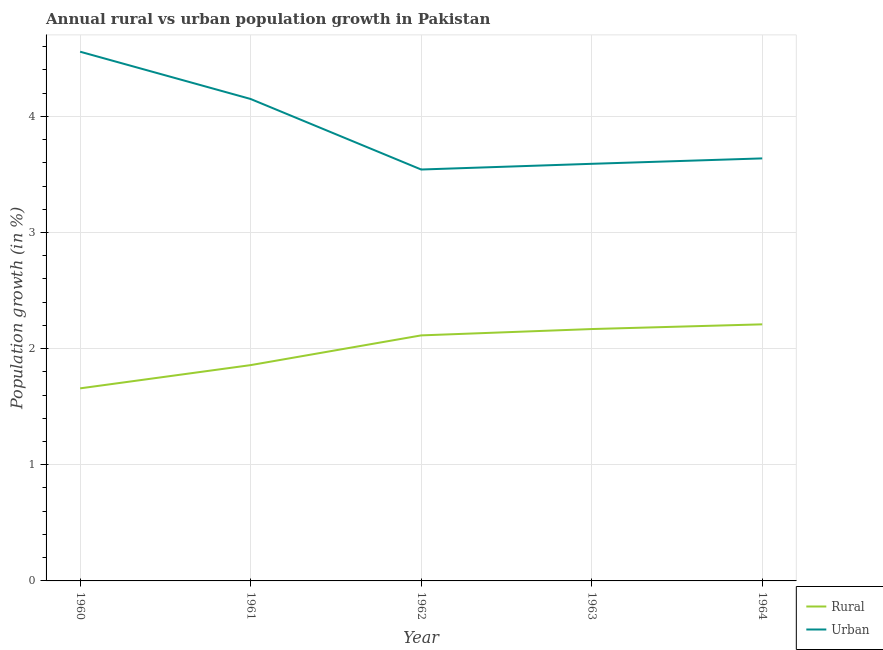How many different coloured lines are there?
Make the answer very short. 2. Is the number of lines equal to the number of legend labels?
Provide a succinct answer. Yes. What is the urban population growth in 1962?
Offer a terse response. 3.54. Across all years, what is the maximum rural population growth?
Ensure brevity in your answer.  2.21. Across all years, what is the minimum rural population growth?
Offer a very short reply. 1.66. In which year was the rural population growth maximum?
Your answer should be very brief. 1964. What is the total urban population growth in the graph?
Ensure brevity in your answer.  19.48. What is the difference between the rural population growth in 1961 and that in 1964?
Make the answer very short. -0.35. What is the difference between the urban population growth in 1960 and the rural population growth in 1962?
Make the answer very short. 2.44. What is the average urban population growth per year?
Your response must be concise. 3.9. In the year 1964, what is the difference between the rural population growth and urban population growth?
Offer a terse response. -1.43. What is the ratio of the rural population growth in 1962 to that in 1964?
Keep it short and to the point. 0.96. Is the urban population growth in 1960 less than that in 1963?
Make the answer very short. No. What is the difference between the highest and the second highest rural population growth?
Provide a succinct answer. 0.04. What is the difference between the highest and the lowest rural population growth?
Keep it short and to the point. 0.55. Is the sum of the rural population growth in 1963 and 1964 greater than the maximum urban population growth across all years?
Your response must be concise. No. Is the rural population growth strictly less than the urban population growth over the years?
Keep it short and to the point. Yes. How many years are there in the graph?
Ensure brevity in your answer.  5. Does the graph contain any zero values?
Keep it short and to the point. No. Where does the legend appear in the graph?
Your answer should be very brief. Bottom right. How many legend labels are there?
Your answer should be compact. 2. How are the legend labels stacked?
Your response must be concise. Vertical. What is the title of the graph?
Make the answer very short. Annual rural vs urban population growth in Pakistan. What is the label or title of the Y-axis?
Offer a very short reply. Population growth (in %). What is the Population growth (in %) of Rural in 1960?
Provide a succinct answer. 1.66. What is the Population growth (in %) in Urban  in 1960?
Provide a short and direct response. 4.56. What is the Population growth (in %) in Rural in 1961?
Your answer should be very brief. 1.86. What is the Population growth (in %) in Urban  in 1961?
Provide a short and direct response. 4.15. What is the Population growth (in %) of Rural in 1962?
Offer a very short reply. 2.11. What is the Population growth (in %) of Urban  in 1962?
Your answer should be very brief. 3.54. What is the Population growth (in %) of Rural in 1963?
Your answer should be compact. 2.17. What is the Population growth (in %) of Urban  in 1963?
Keep it short and to the point. 3.59. What is the Population growth (in %) in Rural in 1964?
Provide a short and direct response. 2.21. What is the Population growth (in %) of Urban  in 1964?
Provide a short and direct response. 3.64. Across all years, what is the maximum Population growth (in %) of Rural?
Your response must be concise. 2.21. Across all years, what is the maximum Population growth (in %) of Urban ?
Give a very brief answer. 4.56. Across all years, what is the minimum Population growth (in %) in Rural?
Give a very brief answer. 1.66. Across all years, what is the minimum Population growth (in %) in Urban ?
Give a very brief answer. 3.54. What is the total Population growth (in %) of Rural in the graph?
Offer a terse response. 10.01. What is the total Population growth (in %) in Urban  in the graph?
Your answer should be compact. 19.48. What is the difference between the Population growth (in %) of Rural in 1960 and that in 1961?
Make the answer very short. -0.2. What is the difference between the Population growth (in %) in Urban  in 1960 and that in 1961?
Provide a succinct answer. 0.41. What is the difference between the Population growth (in %) in Rural in 1960 and that in 1962?
Provide a succinct answer. -0.46. What is the difference between the Population growth (in %) in Urban  in 1960 and that in 1962?
Your response must be concise. 1.01. What is the difference between the Population growth (in %) in Rural in 1960 and that in 1963?
Ensure brevity in your answer.  -0.51. What is the difference between the Population growth (in %) in Urban  in 1960 and that in 1963?
Your response must be concise. 0.97. What is the difference between the Population growth (in %) in Rural in 1960 and that in 1964?
Ensure brevity in your answer.  -0.55. What is the difference between the Population growth (in %) of Urban  in 1960 and that in 1964?
Keep it short and to the point. 0.92. What is the difference between the Population growth (in %) in Rural in 1961 and that in 1962?
Give a very brief answer. -0.26. What is the difference between the Population growth (in %) in Urban  in 1961 and that in 1962?
Your answer should be compact. 0.61. What is the difference between the Population growth (in %) of Rural in 1961 and that in 1963?
Make the answer very short. -0.31. What is the difference between the Population growth (in %) in Urban  in 1961 and that in 1963?
Provide a succinct answer. 0.56. What is the difference between the Population growth (in %) of Rural in 1961 and that in 1964?
Offer a terse response. -0.35. What is the difference between the Population growth (in %) in Urban  in 1961 and that in 1964?
Make the answer very short. 0.51. What is the difference between the Population growth (in %) of Rural in 1962 and that in 1963?
Your response must be concise. -0.05. What is the difference between the Population growth (in %) of Urban  in 1962 and that in 1963?
Your response must be concise. -0.05. What is the difference between the Population growth (in %) of Rural in 1962 and that in 1964?
Give a very brief answer. -0.1. What is the difference between the Population growth (in %) of Urban  in 1962 and that in 1964?
Your answer should be very brief. -0.1. What is the difference between the Population growth (in %) in Rural in 1963 and that in 1964?
Provide a succinct answer. -0.04. What is the difference between the Population growth (in %) of Urban  in 1963 and that in 1964?
Your answer should be compact. -0.05. What is the difference between the Population growth (in %) in Rural in 1960 and the Population growth (in %) in Urban  in 1961?
Provide a short and direct response. -2.49. What is the difference between the Population growth (in %) of Rural in 1960 and the Population growth (in %) of Urban  in 1962?
Provide a short and direct response. -1.88. What is the difference between the Population growth (in %) of Rural in 1960 and the Population growth (in %) of Urban  in 1963?
Offer a terse response. -1.93. What is the difference between the Population growth (in %) in Rural in 1960 and the Population growth (in %) in Urban  in 1964?
Provide a short and direct response. -1.98. What is the difference between the Population growth (in %) of Rural in 1961 and the Population growth (in %) of Urban  in 1962?
Provide a short and direct response. -1.68. What is the difference between the Population growth (in %) in Rural in 1961 and the Population growth (in %) in Urban  in 1963?
Provide a succinct answer. -1.73. What is the difference between the Population growth (in %) of Rural in 1961 and the Population growth (in %) of Urban  in 1964?
Your answer should be very brief. -1.78. What is the difference between the Population growth (in %) in Rural in 1962 and the Population growth (in %) in Urban  in 1963?
Make the answer very short. -1.48. What is the difference between the Population growth (in %) of Rural in 1962 and the Population growth (in %) of Urban  in 1964?
Your answer should be very brief. -1.52. What is the difference between the Population growth (in %) of Rural in 1963 and the Population growth (in %) of Urban  in 1964?
Ensure brevity in your answer.  -1.47. What is the average Population growth (in %) of Rural per year?
Ensure brevity in your answer.  2. What is the average Population growth (in %) of Urban  per year?
Keep it short and to the point. 3.9. In the year 1960, what is the difference between the Population growth (in %) of Rural and Population growth (in %) of Urban ?
Your answer should be very brief. -2.9. In the year 1961, what is the difference between the Population growth (in %) in Rural and Population growth (in %) in Urban ?
Provide a short and direct response. -2.29. In the year 1962, what is the difference between the Population growth (in %) in Rural and Population growth (in %) in Urban ?
Your answer should be very brief. -1.43. In the year 1963, what is the difference between the Population growth (in %) of Rural and Population growth (in %) of Urban ?
Provide a succinct answer. -1.42. In the year 1964, what is the difference between the Population growth (in %) in Rural and Population growth (in %) in Urban ?
Your response must be concise. -1.43. What is the ratio of the Population growth (in %) of Rural in 1960 to that in 1961?
Provide a succinct answer. 0.89. What is the ratio of the Population growth (in %) in Urban  in 1960 to that in 1961?
Make the answer very short. 1.1. What is the ratio of the Population growth (in %) in Rural in 1960 to that in 1962?
Offer a very short reply. 0.78. What is the ratio of the Population growth (in %) of Urban  in 1960 to that in 1962?
Offer a very short reply. 1.29. What is the ratio of the Population growth (in %) of Rural in 1960 to that in 1963?
Make the answer very short. 0.76. What is the ratio of the Population growth (in %) of Urban  in 1960 to that in 1963?
Keep it short and to the point. 1.27. What is the ratio of the Population growth (in %) of Rural in 1960 to that in 1964?
Give a very brief answer. 0.75. What is the ratio of the Population growth (in %) in Urban  in 1960 to that in 1964?
Ensure brevity in your answer.  1.25. What is the ratio of the Population growth (in %) in Rural in 1961 to that in 1962?
Offer a terse response. 0.88. What is the ratio of the Population growth (in %) in Urban  in 1961 to that in 1962?
Provide a succinct answer. 1.17. What is the ratio of the Population growth (in %) of Rural in 1961 to that in 1963?
Make the answer very short. 0.86. What is the ratio of the Population growth (in %) of Urban  in 1961 to that in 1963?
Offer a terse response. 1.16. What is the ratio of the Population growth (in %) of Rural in 1961 to that in 1964?
Give a very brief answer. 0.84. What is the ratio of the Population growth (in %) in Urban  in 1961 to that in 1964?
Offer a terse response. 1.14. What is the ratio of the Population growth (in %) of Rural in 1962 to that in 1963?
Your response must be concise. 0.97. What is the ratio of the Population growth (in %) of Urban  in 1962 to that in 1963?
Ensure brevity in your answer.  0.99. What is the ratio of the Population growth (in %) of Rural in 1962 to that in 1964?
Make the answer very short. 0.96. What is the ratio of the Population growth (in %) in Urban  in 1962 to that in 1964?
Your answer should be very brief. 0.97. What is the ratio of the Population growth (in %) of Rural in 1963 to that in 1964?
Give a very brief answer. 0.98. What is the ratio of the Population growth (in %) in Urban  in 1963 to that in 1964?
Your answer should be compact. 0.99. What is the difference between the highest and the second highest Population growth (in %) of Rural?
Your answer should be very brief. 0.04. What is the difference between the highest and the second highest Population growth (in %) in Urban ?
Ensure brevity in your answer.  0.41. What is the difference between the highest and the lowest Population growth (in %) of Rural?
Your answer should be compact. 0.55. What is the difference between the highest and the lowest Population growth (in %) of Urban ?
Keep it short and to the point. 1.01. 